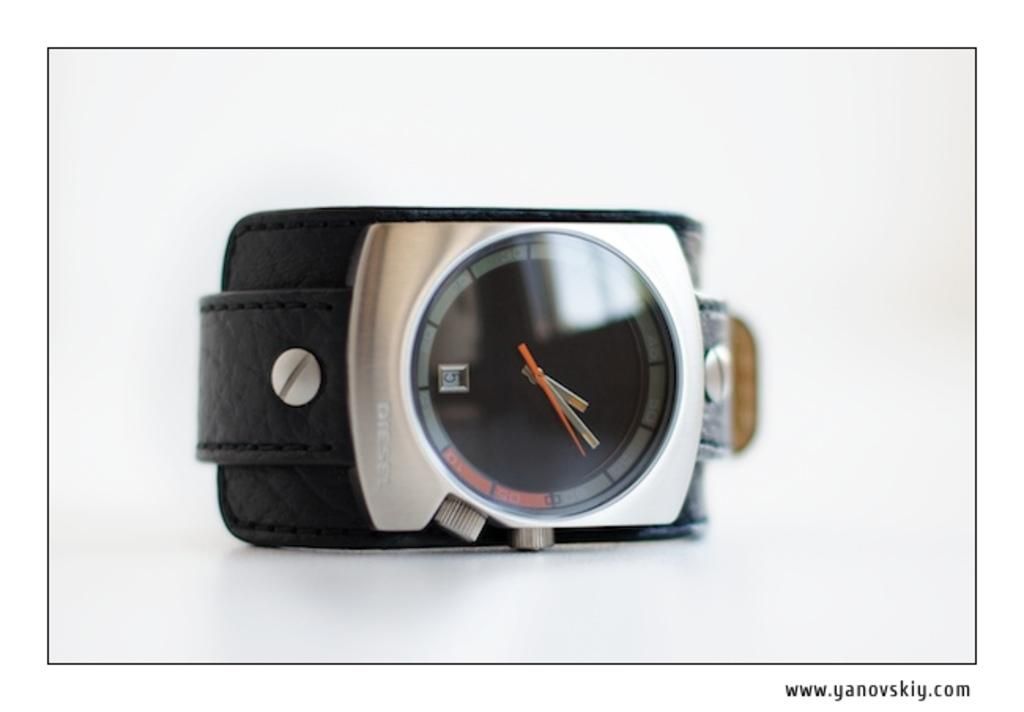<image>
Offer a succinct explanation of the picture presented. A simple modern watch has the number 5 in the date window. 